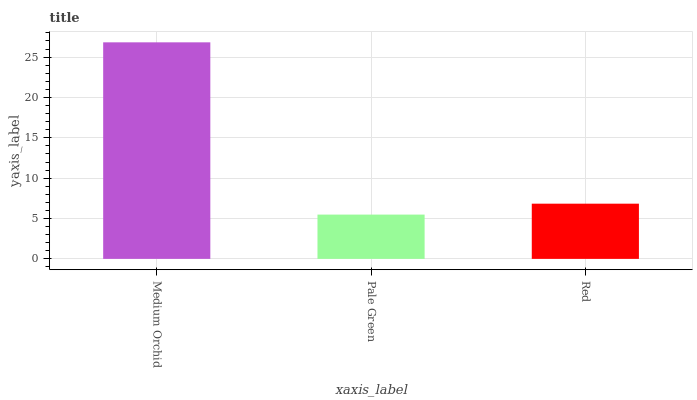Is Pale Green the minimum?
Answer yes or no. Yes. Is Medium Orchid the maximum?
Answer yes or no. Yes. Is Red the minimum?
Answer yes or no. No. Is Red the maximum?
Answer yes or no. No. Is Red greater than Pale Green?
Answer yes or no. Yes. Is Pale Green less than Red?
Answer yes or no. Yes. Is Pale Green greater than Red?
Answer yes or no. No. Is Red less than Pale Green?
Answer yes or no. No. Is Red the high median?
Answer yes or no. Yes. Is Red the low median?
Answer yes or no. Yes. Is Pale Green the high median?
Answer yes or no. No. Is Pale Green the low median?
Answer yes or no. No. 